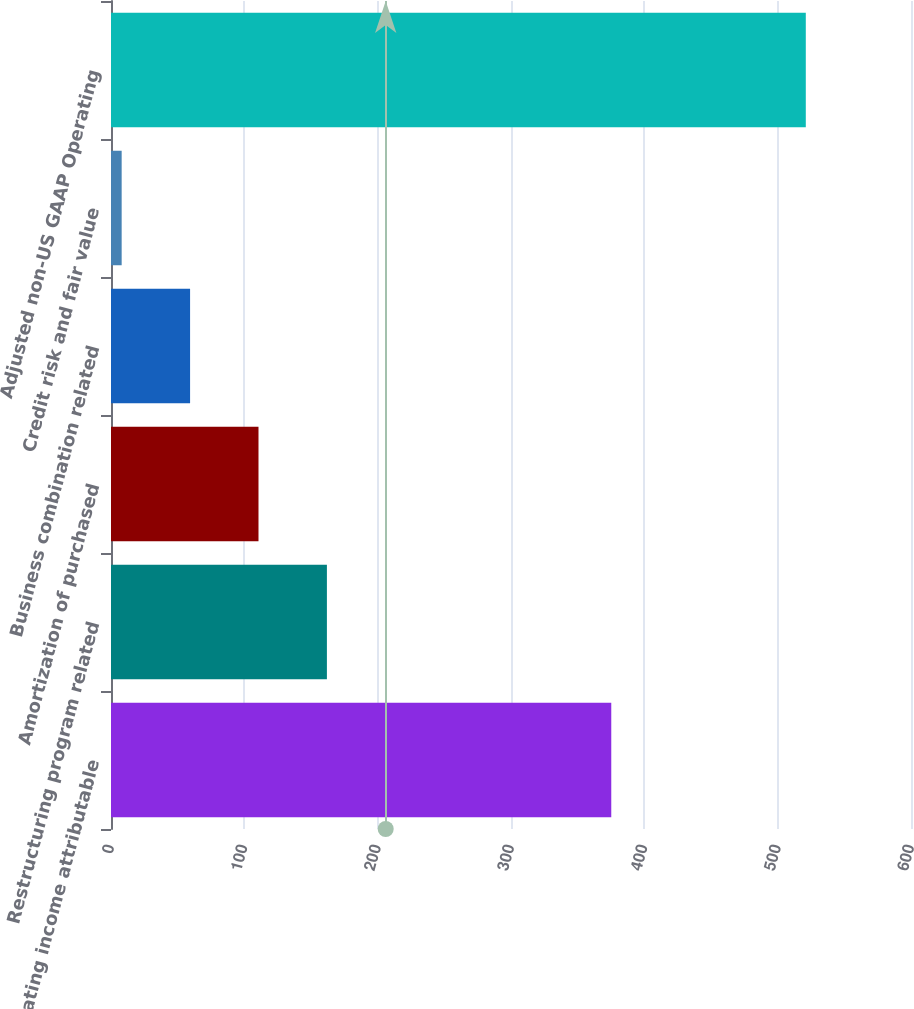Convert chart. <chart><loc_0><loc_0><loc_500><loc_500><bar_chart><fcel>Operating income attributable<fcel>Restructuring program related<fcel>Amortization of purchased<fcel>Business combination related<fcel>Credit risk and fair value<fcel>Adjusted non-US GAAP Operating<nl><fcel>375.2<fcel>161.93<fcel>110.62<fcel>59.31<fcel>8<fcel>521.1<nl></chart> 